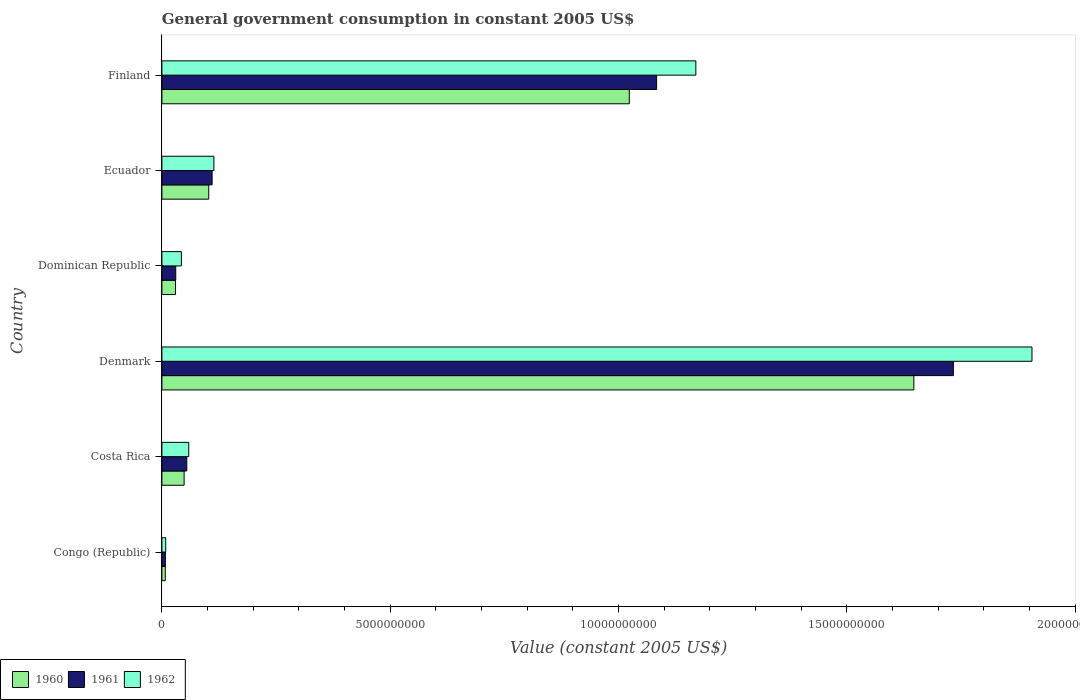How many different coloured bars are there?
Your answer should be very brief. 3. How many bars are there on the 6th tick from the bottom?
Your answer should be compact. 3. What is the label of the 4th group of bars from the top?
Your response must be concise. Denmark. In how many cases, is the number of bars for a given country not equal to the number of legend labels?
Offer a very short reply. 0. What is the government conusmption in 1960 in Ecuador?
Ensure brevity in your answer.  1.03e+09. Across all countries, what is the maximum government conusmption in 1961?
Your response must be concise. 1.73e+1. Across all countries, what is the minimum government conusmption in 1962?
Give a very brief answer. 8.33e+07. In which country was the government conusmption in 1962 maximum?
Provide a short and direct response. Denmark. In which country was the government conusmption in 1960 minimum?
Your answer should be compact. Congo (Republic). What is the total government conusmption in 1960 in the graph?
Ensure brevity in your answer.  2.86e+1. What is the difference between the government conusmption in 1960 in Costa Rica and that in Ecuador?
Ensure brevity in your answer.  -5.39e+08. What is the difference between the government conusmption in 1960 in Finland and the government conusmption in 1961 in Ecuador?
Offer a very short reply. 9.13e+09. What is the average government conusmption in 1961 per country?
Give a very brief answer. 5.03e+09. What is the difference between the government conusmption in 1960 and government conusmption in 1962 in Congo (Republic)?
Give a very brief answer. -8.89e+06. What is the ratio of the government conusmption in 1961 in Congo (Republic) to that in Costa Rica?
Ensure brevity in your answer.  0.14. Is the government conusmption in 1961 in Dominican Republic less than that in Ecuador?
Your response must be concise. Yes. What is the difference between the highest and the second highest government conusmption in 1960?
Your answer should be very brief. 6.23e+09. What is the difference between the highest and the lowest government conusmption in 1962?
Keep it short and to the point. 1.90e+1. Is the sum of the government conusmption in 1962 in Dominican Republic and Finland greater than the maximum government conusmption in 1961 across all countries?
Make the answer very short. No. What does the 1st bar from the bottom in Congo (Republic) represents?
Offer a very short reply. 1960. How many bars are there?
Offer a very short reply. 18. What is the difference between two consecutive major ticks on the X-axis?
Keep it short and to the point. 5.00e+09. What is the title of the graph?
Offer a very short reply. General government consumption in constant 2005 US$. What is the label or title of the X-axis?
Keep it short and to the point. Value (constant 2005 US$). What is the label or title of the Y-axis?
Provide a short and direct response. Country. What is the Value (constant 2005 US$) of 1960 in Congo (Republic)?
Your response must be concise. 7.44e+07. What is the Value (constant 2005 US$) of 1961 in Congo (Republic)?
Keep it short and to the point. 7.67e+07. What is the Value (constant 2005 US$) in 1962 in Congo (Republic)?
Keep it short and to the point. 8.33e+07. What is the Value (constant 2005 US$) of 1960 in Costa Rica?
Your answer should be compact. 4.87e+08. What is the Value (constant 2005 US$) of 1961 in Costa Rica?
Make the answer very short. 5.45e+08. What is the Value (constant 2005 US$) of 1962 in Costa Rica?
Keep it short and to the point. 5.88e+08. What is the Value (constant 2005 US$) of 1960 in Denmark?
Keep it short and to the point. 1.65e+1. What is the Value (constant 2005 US$) of 1961 in Denmark?
Ensure brevity in your answer.  1.73e+1. What is the Value (constant 2005 US$) of 1962 in Denmark?
Keep it short and to the point. 1.91e+1. What is the Value (constant 2005 US$) in 1960 in Dominican Republic?
Provide a succinct answer. 2.99e+08. What is the Value (constant 2005 US$) in 1961 in Dominican Republic?
Your answer should be very brief. 3.03e+08. What is the Value (constant 2005 US$) of 1962 in Dominican Republic?
Your answer should be compact. 4.27e+08. What is the Value (constant 2005 US$) of 1960 in Ecuador?
Make the answer very short. 1.03e+09. What is the Value (constant 2005 US$) in 1961 in Ecuador?
Your answer should be compact. 1.10e+09. What is the Value (constant 2005 US$) in 1962 in Ecuador?
Make the answer very short. 1.14e+09. What is the Value (constant 2005 US$) of 1960 in Finland?
Offer a very short reply. 1.02e+1. What is the Value (constant 2005 US$) of 1961 in Finland?
Provide a succinct answer. 1.08e+1. What is the Value (constant 2005 US$) of 1962 in Finland?
Provide a short and direct response. 1.17e+1. Across all countries, what is the maximum Value (constant 2005 US$) in 1960?
Provide a short and direct response. 1.65e+1. Across all countries, what is the maximum Value (constant 2005 US$) of 1961?
Give a very brief answer. 1.73e+1. Across all countries, what is the maximum Value (constant 2005 US$) of 1962?
Provide a short and direct response. 1.91e+1. Across all countries, what is the minimum Value (constant 2005 US$) in 1960?
Your response must be concise. 7.44e+07. Across all countries, what is the minimum Value (constant 2005 US$) in 1961?
Offer a very short reply. 7.67e+07. Across all countries, what is the minimum Value (constant 2005 US$) in 1962?
Your answer should be compact. 8.33e+07. What is the total Value (constant 2005 US$) of 1960 in the graph?
Offer a very short reply. 2.86e+1. What is the total Value (constant 2005 US$) in 1961 in the graph?
Your answer should be compact. 3.02e+1. What is the total Value (constant 2005 US$) of 1962 in the graph?
Give a very brief answer. 3.30e+1. What is the difference between the Value (constant 2005 US$) of 1960 in Congo (Republic) and that in Costa Rica?
Ensure brevity in your answer.  -4.12e+08. What is the difference between the Value (constant 2005 US$) in 1961 in Congo (Republic) and that in Costa Rica?
Offer a very short reply. -4.68e+08. What is the difference between the Value (constant 2005 US$) in 1962 in Congo (Republic) and that in Costa Rica?
Offer a terse response. -5.05e+08. What is the difference between the Value (constant 2005 US$) of 1960 in Congo (Republic) and that in Denmark?
Give a very brief answer. -1.64e+1. What is the difference between the Value (constant 2005 US$) of 1961 in Congo (Republic) and that in Denmark?
Provide a succinct answer. -1.73e+1. What is the difference between the Value (constant 2005 US$) in 1962 in Congo (Republic) and that in Denmark?
Provide a succinct answer. -1.90e+1. What is the difference between the Value (constant 2005 US$) in 1960 in Congo (Republic) and that in Dominican Republic?
Your answer should be compact. -2.24e+08. What is the difference between the Value (constant 2005 US$) in 1961 in Congo (Republic) and that in Dominican Republic?
Provide a short and direct response. -2.27e+08. What is the difference between the Value (constant 2005 US$) of 1962 in Congo (Republic) and that in Dominican Republic?
Your answer should be very brief. -3.43e+08. What is the difference between the Value (constant 2005 US$) of 1960 in Congo (Republic) and that in Ecuador?
Your answer should be compact. -9.51e+08. What is the difference between the Value (constant 2005 US$) in 1961 in Congo (Republic) and that in Ecuador?
Your answer should be very brief. -1.02e+09. What is the difference between the Value (constant 2005 US$) of 1962 in Congo (Republic) and that in Ecuador?
Your answer should be very brief. -1.05e+09. What is the difference between the Value (constant 2005 US$) in 1960 in Congo (Republic) and that in Finland?
Keep it short and to the point. -1.02e+1. What is the difference between the Value (constant 2005 US$) in 1961 in Congo (Republic) and that in Finland?
Offer a terse response. -1.08e+1. What is the difference between the Value (constant 2005 US$) of 1962 in Congo (Republic) and that in Finland?
Provide a succinct answer. -1.16e+1. What is the difference between the Value (constant 2005 US$) in 1960 in Costa Rica and that in Denmark?
Offer a terse response. -1.60e+1. What is the difference between the Value (constant 2005 US$) in 1961 in Costa Rica and that in Denmark?
Provide a succinct answer. -1.68e+1. What is the difference between the Value (constant 2005 US$) in 1962 in Costa Rica and that in Denmark?
Provide a short and direct response. -1.85e+1. What is the difference between the Value (constant 2005 US$) of 1960 in Costa Rica and that in Dominican Republic?
Ensure brevity in your answer.  1.88e+08. What is the difference between the Value (constant 2005 US$) in 1961 in Costa Rica and that in Dominican Republic?
Your response must be concise. 2.41e+08. What is the difference between the Value (constant 2005 US$) in 1962 in Costa Rica and that in Dominican Republic?
Provide a short and direct response. 1.61e+08. What is the difference between the Value (constant 2005 US$) in 1960 in Costa Rica and that in Ecuador?
Make the answer very short. -5.39e+08. What is the difference between the Value (constant 2005 US$) in 1961 in Costa Rica and that in Ecuador?
Provide a succinct answer. -5.55e+08. What is the difference between the Value (constant 2005 US$) in 1962 in Costa Rica and that in Ecuador?
Provide a short and direct response. -5.50e+08. What is the difference between the Value (constant 2005 US$) in 1960 in Costa Rica and that in Finland?
Offer a very short reply. -9.75e+09. What is the difference between the Value (constant 2005 US$) of 1961 in Costa Rica and that in Finland?
Keep it short and to the point. -1.03e+1. What is the difference between the Value (constant 2005 US$) in 1962 in Costa Rica and that in Finland?
Ensure brevity in your answer.  -1.11e+1. What is the difference between the Value (constant 2005 US$) in 1960 in Denmark and that in Dominican Republic?
Give a very brief answer. 1.62e+1. What is the difference between the Value (constant 2005 US$) in 1961 in Denmark and that in Dominican Republic?
Make the answer very short. 1.70e+1. What is the difference between the Value (constant 2005 US$) in 1962 in Denmark and that in Dominican Republic?
Offer a very short reply. 1.86e+1. What is the difference between the Value (constant 2005 US$) in 1960 in Denmark and that in Ecuador?
Keep it short and to the point. 1.54e+1. What is the difference between the Value (constant 2005 US$) in 1961 in Denmark and that in Ecuador?
Keep it short and to the point. 1.62e+1. What is the difference between the Value (constant 2005 US$) in 1962 in Denmark and that in Ecuador?
Offer a terse response. 1.79e+1. What is the difference between the Value (constant 2005 US$) of 1960 in Denmark and that in Finland?
Your answer should be very brief. 6.23e+09. What is the difference between the Value (constant 2005 US$) of 1961 in Denmark and that in Finland?
Ensure brevity in your answer.  6.50e+09. What is the difference between the Value (constant 2005 US$) of 1962 in Denmark and that in Finland?
Keep it short and to the point. 7.36e+09. What is the difference between the Value (constant 2005 US$) in 1960 in Dominican Republic and that in Ecuador?
Ensure brevity in your answer.  -7.27e+08. What is the difference between the Value (constant 2005 US$) in 1961 in Dominican Republic and that in Ecuador?
Provide a succinct answer. -7.96e+08. What is the difference between the Value (constant 2005 US$) in 1962 in Dominican Republic and that in Ecuador?
Offer a very short reply. -7.11e+08. What is the difference between the Value (constant 2005 US$) of 1960 in Dominican Republic and that in Finland?
Keep it short and to the point. -9.94e+09. What is the difference between the Value (constant 2005 US$) of 1961 in Dominican Republic and that in Finland?
Provide a succinct answer. -1.05e+1. What is the difference between the Value (constant 2005 US$) in 1962 in Dominican Republic and that in Finland?
Your answer should be compact. -1.13e+1. What is the difference between the Value (constant 2005 US$) of 1960 in Ecuador and that in Finland?
Give a very brief answer. -9.21e+09. What is the difference between the Value (constant 2005 US$) of 1961 in Ecuador and that in Finland?
Offer a terse response. -9.73e+09. What is the difference between the Value (constant 2005 US$) in 1962 in Ecuador and that in Finland?
Offer a terse response. -1.06e+1. What is the difference between the Value (constant 2005 US$) of 1960 in Congo (Republic) and the Value (constant 2005 US$) of 1961 in Costa Rica?
Offer a terse response. -4.70e+08. What is the difference between the Value (constant 2005 US$) of 1960 in Congo (Republic) and the Value (constant 2005 US$) of 1962 in Costa Rica?
Your answer should be compact. -5.13e+08. What is the difference between the Value (constant 2005 US$) of 1961 in Congo (Republic) and the Value (constant 2005 US$) of 1962 in Costa Rica?
Your response must be concise. -5.11e+08. What is the difference between the Value (constant 2005 US$) of 1960 in Congo (Republic) and the Value (constant 2005 US$) of 1961 in Denmark?
Provide a succinct answer. -1.73e+1. What is the difference between the Value (constant 2005 US$) of 1960 in Congo (Republic) and the Value (constant 2005 US$) of 1962 in Denmark?
Make the answer very short. -1.90e+1. What is the difference between the Value (constant 2005 US$) in 1961 in Congo (Republic) and the Value (constant 2005 US$) in 1962 in Denmark?
Provide a short and direct response. -1.90e+1. What is the difference between the Value (constant 2005 US$) in 1960 in Congo (Republic) and the Value (constant 2005 US$) in 1961 in Dominican Republic?
Offer a very short reply. -2.29e+08. What is the difference between the Value (constant 2005 US$) of 1960 in Congo (Republic) and the Value (constant 2005 US$) of 1962 in Dominican Republic?
Your answer should be very brief. -3.52e+08. What is the difference between the Value (constant 2005 US$) of 1961 in Congo (Republic) and the Value (constant 2005 US$) of 1962 in Dominican Republic?
Ensure brevity in your answer.  -3.50e+08. What is the difference between the Value (constant 2005 US$) in 1960 in Congo (Republic) and the Value (constant 2005 US$) in 1961 in Ecuador?
Make the answer very short. -1.02e+09. What is the difference between the Value (constant 2005 US$) in 1960 in Congo (Republic) and the Value (constant 2005 US$) in 1962 in Ecuador?
Offer a terse response. -1.06e+09. What is the difference between the Value (constant 2005 US$) of 1961 in Congo (Republic) and the Value (constant 2005 US$) of 1962 in Ecuador?
Your answer should be compact. -1.06e+09. What is the difference between the Value (constant 2005 US$) in 1960 in Congo (Republic) and the Value (constant 2005 US$) in 1961 in Finland?
Make the answer very short. -1.08e+1. What is the difference between the Value (constant 2005 US$) of 1960 in Congo (Republic) and the Value (constant 2005 US$) of 1962 in Finland?
Your response must be concise. -1.16e+1. What is the difference between the Value (constant 2005 US$) in 1961 in Congo (Republic) and the Value (constant 2005 US$) in 1962 in Finland?
Make the answer very short. -1.16e+1. What is the difference between the Value (constant 2005 US$) in 1960 in Costa Rica and the Value (constant 2005 US$) in 1961 in Denmark?
Keep it short and to the point. -1.68e+1. What is the difference between the Value (constant 2005 US$) of 1960 in Costa Rica and the Value (constant 2005 US$) of 1962 in Denmark?
Make the answer very short. -1.86e+1. What is the difference between the Value (constant 2005 US$) of 1961 in Costa Rica and the Value (constant 2005 US$) of 1962 in Denmark?
Offer a terse response. -1.85e+1. What is the difference between the Value (constant 2005 US$) of 1960 in Costa Rica and the Value (constant 2005 US$) of 1961 in Dominican Republic?
Keep it short and to the point. 1.83e+08. What is the difference between the Value (constant 2005 US$) in 1960 in Costa Rica and the Value (constant 2005 US$) in 1962 in Dominican Republic?
Make the answer very short. 6.01e+07. What is the difference between the Value (constant 2005 US$) in 1961 in Costa Rica and the Value (constant 2005 US$) in 1962 in Dominican Republic?
Provide a succinct answer. 1.18e+08. What is the difference between the Value (constant 2005 US$) in 1960 in Costa Rica and the Value (constant 2005 US$) in 1961 in Ecuador?
Offer a very short reply. -6.13e+08. What is the difference between the Value (constant 2005 US$) in 1960 in Costa Rica and the Value (constant 2005 US$) in 1962 in Ecuador?
Ensure brevity in your answer.  -6.51e+08. What is the difference between the Value (constant 2005 US$) in 1961 in Costa Rica and the Value (constant 2005 US$) in 1962 in Ecuador?
Make the answer very short. -5.93e+08. What is the difference between the Value (constant 2005 US$) of 1960 in Costa Rica and the Value (constant 2005 US$) of 1961 in Finland?
Your answer should be compact. -1.03e+1. What is the difference between the Value (constant 2005 US$) in 1960 in Costa Rica and the Value (constant 2005 US$) in 1962 in Finland?
Provide a succinct answer. -1.12e+1. What is the difference between the Value (constant 2005 US$) of 1961 in Costa Rica and the Value (constant 2005 US$) of 1962 in Finland?
Your response must be concise. -1.11e+1. What is the difference between the Value (constant 2005 US$) of 1960 in Denmark and the Value (constant 2005 US$) of 1961 in Dominican Republic?
Keep it short and to the point. 1.62e+1. What is the difference between the Value (constant 2005 US$) in 1960 in Denmark and the Value (constant 2005 US$) in 1962 in Dominican Republic?
Offer a terse response. 1.60e+1. What is the difference between the Value (constant 2005 US$) in 1961 in Denmark and the Value (constant 2005 US$) in 1962 in Dominican Republic?
Make the answer very short. 1.69e+1. What is the difference between the Value (constant 2005 US$) of 1960 in Denmark and the Value (constant 2005 US$) of 1961 in Ecuador?
Your answer should be compact. 1.54e+1. What is the difference between the Value (constant 2005 US$) of 1960 in Denmark and the Value (constant 2005 US$) of 1962 in Ecuador?
Your answer should be very brief. 1.53e+1. What is the difference between the Value (constant 2005 US$) in 1961 in Denmark and the Value (constant 2005 US$) in 1962 in Ecuador?
Provide a succinct answer. 1.62e+1. What is the difference between the Value (constant 2005 US$) of 1960 in Denmark and the Value (constant 2005 US$) of 1961 in Finland?
Provide a succinct answer. 5.63e+09. What is the difference between the Value (constant 2005 US$) in 1960 in Denmark and the Value (constant 2005 US$) in 1962 in Finland?
Give a very brief answer. 4.77e+09. What is the difference between the Value (constant 2005 US$) of 1961 in Denmark and the Value (constant 2005 US$) of 1962 in Finland?
Your answer should be very brief. 5.64e+09. What is the difference between the Value (constant 2005 US$) in 1960 in Dominican Republic and the Value (constant 2005 US$) in 1961 in Ecuador?
Give a very brief answer. -8.01e+08. What is the difference between the Value (constant 2005 US$) of 1960 in Dominican Republic and the Value (constant 2005 US$) of 1962 in Ecuador?
Give a very brief answer. -8.39e+08. What is the difference between the Value (constant 2005 US$) of 1961 in Dominican Republic and the Value (constant 2005 US$) of 1962 in Ecuador?
Your answer should be very brief. -8.35e+08. What is the difference between the Value (constant 2005 US$) in 1960 in Dominican Republic and the Value (constant 2005 US$) in 1961 in Finland?
Provide a succinct answer. -1.05e+1. What is the difference between the Value (constant 2005 US$) of 1960 in Dominican Republic and the Value (constant 2005 US$) of 1962 in Finland?
Provide a succinct answer. -1.14e+1. What is the difference between the Value (constant 2005 US$) in 1961 in Dominican Republic and the Value (constant 2005 US$) in 1962 in Finland?
Ensure brevity in your answer.  -1.14e+1. What is the difference between the Value (constant 2005 US$) in 1960 in Ecuador and the Value (constant 2005 US$) in 1961 in Finland?
Your answer should be very brief. -9.81e+09. What is the difference between the Value (constant 2005 US$) in 1960 in Ecuador and the Value (constant 2005 US$) in 1962 in Finland?
Make the answer very short. -1.07e+1. What is the difference between the Value (constant 2005 US$) in 1961 in Ecuador and the Value (constant 2005 US$) in 1962 in Finland?
Ensure brevity in your answer.  -1.06e+1. What is the average Value (constant 2005 US$) of 1960 per country?
Give a very brief answer. 4.76e+09. What is the average Value (constant 2005 US$) of 1961 per country?
Ensure brevity in your answer.  5.03e+09. What is the average Value (constant 2005 US$) in 1962 per country?
Offer a very short reply. 5.50e+09. What is the difference between the Value (constant 2005 US$) of 1960 and Value (constant 2005 US$) of 1961 in Congo (Republic)?
Your response must be concise. -2.22e+06. What is the difference between the Value (constant 2005 US$) of 1960 and Value (constant 2005 US$) of 1962 in Congo (Republic)?
Give a very brief answer. -8.89e+06. What is the difference between the Value (constant 2005 US$) of 1961 and Value (constant 2005 US$) of 1962 in Congo (Republic)?
Keep it short and to the point. -6.67e+06. What is the difference between the Value (constant 2005 US$) in 1960 and Value (constant 2005 US$) in 1961 in Costa Rica?
Offer a very short reply. -5.79e+07. What is the difference between the Value (constant 2005 US$) in 1960 and Value (constant 2005 US$) in 1962 in Costa Rica?
Ensure brevity in your answer.  -1.01e+08. What is the difference between the Value (constant 2005 US$) of 1961 and Value (constant 2005 US$) of 1962 in Costa Rica?
Your answer should be very brief. -4.32e+07. What is the difference between the Value (constant 2005 US$) in 1960 and Value (constant 2005 US$) in 1961 in Denmark?
Provide a short and direct response. -8.65e+08. What is the difference between the Value (constant 2005 US$) in 1960 and Value (constant 2005 US$) in 1962 in Denmark?
Make the answer very short. -2.59e+09. What is the difference between the Value (constant 2005 US$) of 1961 and Value (constant 2005 US$) of 1962 in Denmark?
Your answer should be compact. -1.72e+09. What is the difference between the Value (constant 2005 US$) in 1960 and Value (constant 2005 US$) in 1961 in Dominican Republic?
Your answer should be very brief. -4.75e+06. What is the difference between the Value (constant 2005 US$) of 1960 and Value (constant 2005 US$) of 1962 in Dominican Republic?
Ensure brevity in your answer.  -1.28e+08. What is the difference between the Value (constant 2005 US$) of 1961 and Value (constant 2005 US$) of 1962 in Dominican Republic?
Offer a very short reply. -1.23e+08. What is the difference between the Value (constant 2005 US$) in 1960 and Value (constant 2005 US$) in 1961 in Ecuador?
Offer a very short reply. -7.35e+07. What is the difference between the Value (constant 2005 US$) of 1960 and Value (constant 2005 US$) of 1962 in Ecuador?
Keep it short and to the point. -1.12e+08. What is the difference between the Value (constant 2005 US$) of 1961 and Value (constant 2005 US$) of 1962 in Ecuador?
Your answer should be very brief. -3.85e+07. What is the difference between the Value (constant 2005 US$) in 1960 and Value (constant 2005 US$) in 1961 in Finland?
Ensure brevity in your answer.  -5.98e+08. What is the difference between the Value (constant 2005 US$) in 1960 and Value (constant 2005 US$) in 1962 in Finland?
Provide a succinct answer. -1.46e+09. What is the difference between the Value (constant 2005 US$) of 1961 and Value (constant 2005 US$) of 1962 in Finland?
Your answer should be compact. -8.59e+08. What is the ratio of the Value (constant 2005 US$) of 1960 in Congo (Republic) to that in Costa Rica?
Offer a terse response. 0.15. What is the ratio of the Value (constant 2005 US$) in 1961 in Congo (Republic) to that in Costa Rica?
Provide a short and direct response. 0.14. What is the ratio of the Value (constant 2005 US$) in 1962 in Congo (Republic) to that in Costa Rica?
Your answer should be very brief. 0.14. What is the ratio of the Value (constant 2005 US$) in 1960 in Congo (Republic) to that in Denmark?
Give a very brief answer. 0. What is the ratio of the Value (constant 2005 US$) in 1961 in Congo (Republic) to that in Denmark?
Your answer should be compact. 0. What is the ratio of the Value (constant 2005 US$) of 1962 in Congo (Republic) to that in Denmark?
Give a very brief answer. 0. What is the ratio of the Value (constant 2005 US$) in 1960 in Congo (Republic) to that in Dominican Republic?
Give a very brief answer. 0.25. What is the ratio of the Value (constant 2005 US$) of 1961 in Congo (Republic) to that in Dominican Republic?
Provide a short and direct response. 0.25. What is the ratio of the Value (constant 2005 US$) of 1962 in Congo (Republic) to that in Dominican Republic?
Your answer should be compact. 0.2. What is the ratio of the Value (constant 2005 US$) of 1960 in Congo (Republic) to that in Ecuador?
Your answer should be compact. 0.07. What is the ratio of the Value (constant 2005 US$) of 1961 in Congo (Republic) to that in Ecuador?
Make the answer very short. 0.07. What is the ratio of the Value (constant 2005 US$) in 1962 in Congo (Republic) to that in Ecuador?
Ensure brevity in your answer.  0.07. What is the ratio of the Value (constant 2005 US$) in 1960 in Congo (Republic) to that in Finland?
Offer a terse response. 0.01. What is the ratio of the Value (constant 2005 US$) of 1961 in Congo (Republic) to that in Finland?
Your answer should be compact. 0.01. What is the ratio of the Value (constant 2005 US$) of 1962 in Congo (Republic) to that in Finland?
Make the answer very short. 0.01. What is the ratio of the Value (constant 2005 US$) in 1960 in Costa Rica to that in Denmark?
Offer a very short reply. 0.03. What is the ratio of the Value (constant 2005 US$) of 1961 in Costa Rica to that in Denmark?
Offer a terse response. 0.03. What is the ratio of the Value (constant 2005 US$) in 1962 in Costa Rica to that in Denmark?
Offer a very short reply. 0.03. What is the ratio of the Value (constant 2005 US$) of 1960 in Costa Rica to that in Dominican Republic?
Offer a very short reply. 1.63. What is the ratio of the Value (constant 2005 US$) of 1961 in Costa Rica to that in Dominican Republic?
Offer a very short reply. 1.8. What is the ratio of the Value (constant 2005 US$) of 1962 in Costa Rica to that in Dominican Republic?
Your answer should be compact. 1.38. What is the ratio of the Value (constant 2005 US$) of 1960 in Costa Rica to that in Ecuador?
Your answer should be very brief. 0.47. What is the ratio of the Value (constant 2005 US$) of 1961 in Costa Rica to that in Ecuador?
Your answer should be very brief. 0.5. What is the ratio of the Value (constant 2005 US$) in 1962 in Costa Rica to that in Ecuador?
Provide a short and direct response. 0.52. What is the ratio of the Value (constant 2005 US$) of 1960 in Costa Rica to that in Finland?
Your response must be concise. 0.05. What is the ratio of the Value (constant 2005 US$) of 1961 in Costa Rica to that in Finland?
Provide a short and direct response. 0.05. What is the ratio of the Value (constant 2005 US$) of 1962 in Costa Rica to that in Finland?
Keep it short and to the point. 0.05. What is the ratio of the Value (constant 2005 US$) of 1960 in Denmark to that in Dominican Republic?
Offer a very short reply. 55.14. What is the ratio of the Value (constant 2005 US$) in 1961 in Denmark to that in Dominican Republic?
Your answer should be compact. 57.13. What is the ratio of the Value (constant 2005 US$) of 1962 in Denmark to that in Dominican Republic?
Your answer should be compact. 44.66. What is the ratio of the Value (constant 2005 US$) of 1960 in Denmark to that in Ecuador?
Provide a short and direct response. 16.05. What is the ratio of the Value (constant 2005 US$) of 1961 in Denmark to that in Ecuador?
Provide a succinct answer. 15.76. What is the ratio of the Value (constant 2005 US$) of 1962 in Denmark to that in Ecuador?
Offer a very short reply. 16.74. What is the ratio of the Value (constant 2005 US$) of 1960 in Denmark to that in Finland?
Give a very brief answer. 1.61. What is the ratio of the Value (constant 2005 US$) of 1961 in Denmark to that in Finland?
Your response must be concise. 1.6. What is the ratio of the Value (constant 2005 US$) in 1962 in Denmark to that in Finland?
Your response must be concise. 1.63. What is the ratio of the Value (constant 2005 US$) in 1960 in Dominican Republic to that in Ecuador?
Provide a short and direct response. 0.29. What is the ratio of the Value (constant 2005 US$) of 1961 in Dominican Republic to that in Ecuador?
Offer a terse response. 0.28. What is the ratio of the Value (constant 2005 US$) in 1962 in Dominican Republic to that in Ecuador?
Your answer should be very brief. 0.37. What is the ratio of the Value (constant 2005 US$) of 1960 in Dominican Republic to that in Finland?
Give a very brief answer. 0.03. What is the ratio of the Value (constant 2005 US$) in 1961 in Dominican Republic to that in Finland?
Provide a succinct answer. 0.03. What is the ratio of the Value (constant 2005 US$) of 1962 in Dominican Republic to that in Finland?
Keep it short and to the point. 0.04. What is the ratio of the Value (constant 2005 US$) of 1960 in Ecuador to that in Finland?
Give a very brief answer. 0.1. What is the ratio of the Value (constant 2005 US$) of 1961 in Ecuador to that in Finland?
Give a very brief answer. 0.1. What is the ratio of the Value (constant 2005 US$) of 1962 in Ecuador to that in Finland?
Your response must be concise. 0.1. What is the difference between the highest and the second highest Value (constant 2005 US$) in 1960?
Your answer should be very brief. 6.23e+09. What is the difference between the highest and the second highest Value (constant 2005 US$) in 1961?
Give a very brief answer. 6.50e+09. What is the difference between the highest and the second highest Value (constant 2005 US$) of 1962?
Provide a short and direct response. 7.36e+09. What is the difference between the highest and the lowest Value (constant 2005 US$) in 1960?
Keep it short and to the point. 1.64e+1. What is the difference between the highest and the lowest Value (constant 2005 US$) in 1961?
Your answer should be very brief. 1.73e+1. What is the difference between the highest and the lowest Value (constant 2005 US$) of 1962?
Offer a terse response. 1.90e+1. 